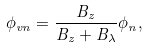<formula> <loc_0><loc_0><loc_500><loc_500>\phi _ { v n } = \frac { B _ { z } } { B _ { z } + B _ { \lambda } } \phi _ { n } ,</formula> 